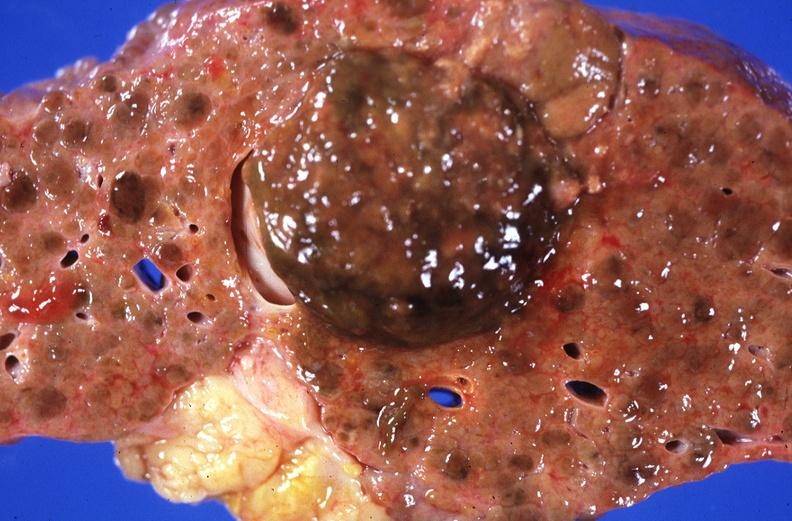what is present?
Answer the question using a single word or phrase. Hepatobiliary 